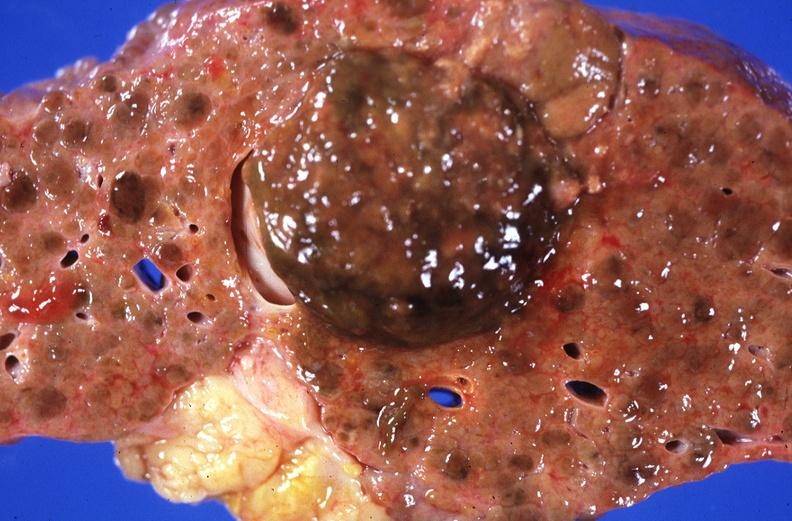what is present?
Answer the question using a single word or phrase. Hepatobiliary 